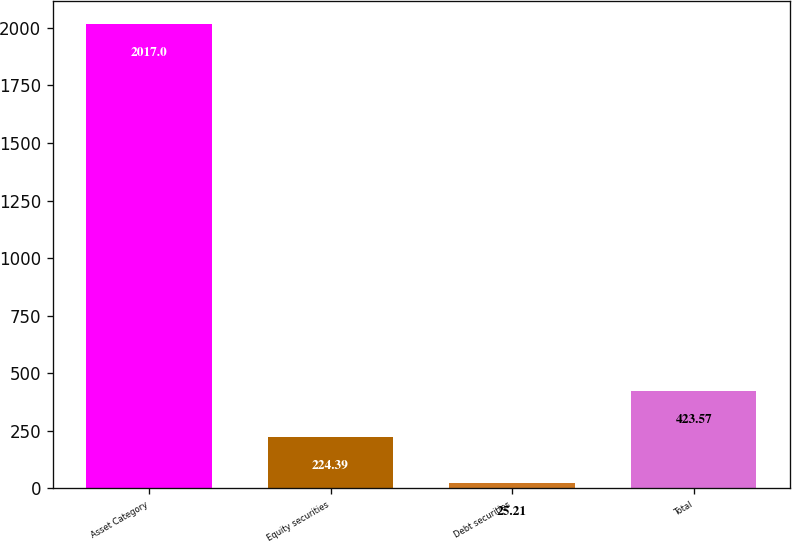Convert chart. <chart><loc_0><loc_0><loc_500><loc_500><bar_chart><fcel>Asset Category<fcel>Equity securities<fcel>Debt securities<fcel>Total<nl><fcel>2017<fcel>224.39<fcel>25.21<fcel>423.57<nl></chart> 